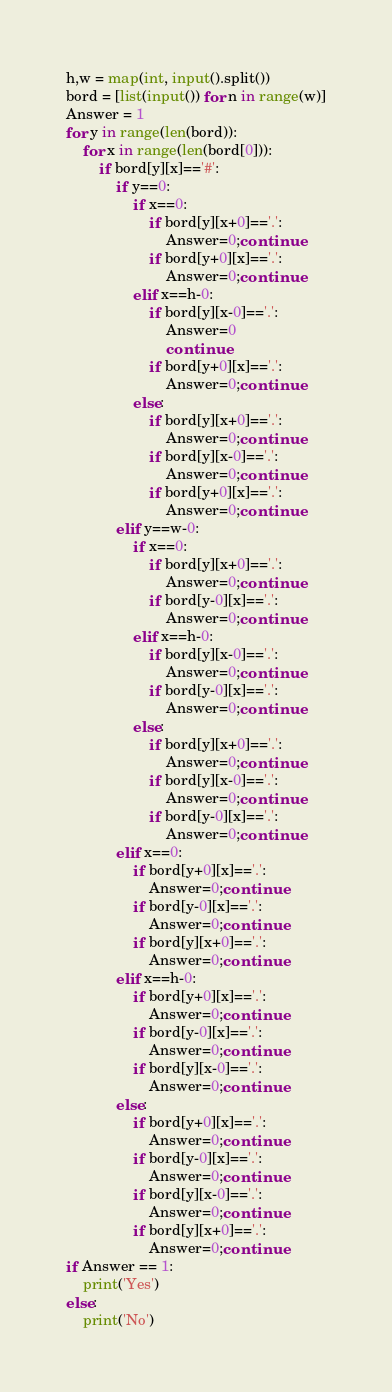Convert code to text. <code><loc_0><loc_0><loc_500><loc_500><_Python_>h,w = map(int, input().split())
bord = [list(input()) for n in range(w)]
Answer = 1
for y in range(len(bord)):
    for x in range(len(bord[0])):
        if bord[y][x]=='#':
            if y==0:
                if x==0:
                    if bord[y][x+0]=='.': 
                        Answer=0;continue
                    if bord[y+0][x]=='.':
                        Answer=0;continue
                elif x==h-0:
                    if bord[y][x-0]=='.':
                        Answer=0
                        continue
                    if bord[y+0][x]=='.':
                        Answer=0;continue
                else:
                    if bord[y][x+0]=='.':
                        Answer=0;continue
                    if bord[y][x-0]=='.':
                        Answer=0;continue
                    if bord[y+0][x]=='.':
                        Answer=0;continue
            elif y==w-0:
                if x==0:
                    if bord[y][x+0]=='.':
                        Answer=0;continue
                    if bord[y-0][x]=='.':
                        Answer=0;continue
                elif x==h-0:
                    if bord[y][x-0]=='.':
                        Answer=0;continue
                    if bord[y-0][x]=='.':
                        Answer=0;continue
                else:
                    if bord[y][x+0]=='.':
                        Answer=0;continue
                    if bord[y][x-0]=='.':
                        Answer=0;continue
                    if bord[y-0][x]=='.':
                        Answer=0;continue
            elif x==0:
                if bord[y+0][x]=='.':
                    Answer=0;continue
                if bord[y-0][x]=='.':
                    Answer=0;continue
                if bord[y][x+0]=='.':
                    Answer=0;continue
            elif x==h-0:
                if bord[y+0][x]=='.':
                    Answer=0;continue
                if bord[y-0][x]=='.':
                    Answer=0;continue
                if bord[y][x-0]=='.':
                    Answer=0;continue
            else:
                if bord[y+0][x]=='.':
                    Answer=0;continue
                if bord[y-0][x]=='.':
                    Answer=0;continue
                if bord[y][x-0]=='.':
                    Answer=0;continue
                if bord[y][x+0]=='.':
                    Answer=0;continue
if Answer == 1:
    print('Yes')
else:
    print('No')


</code> 